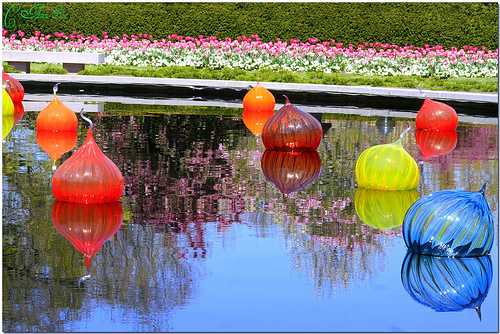<image>
Can you confirm if the water is next to the flowers? Yes. The water is positioned adjacent to the flowers, located nearby in the same general area. Is the ball above the water? Yes. The ball is positioned above the water in the vertical space, higher up in the scene. 